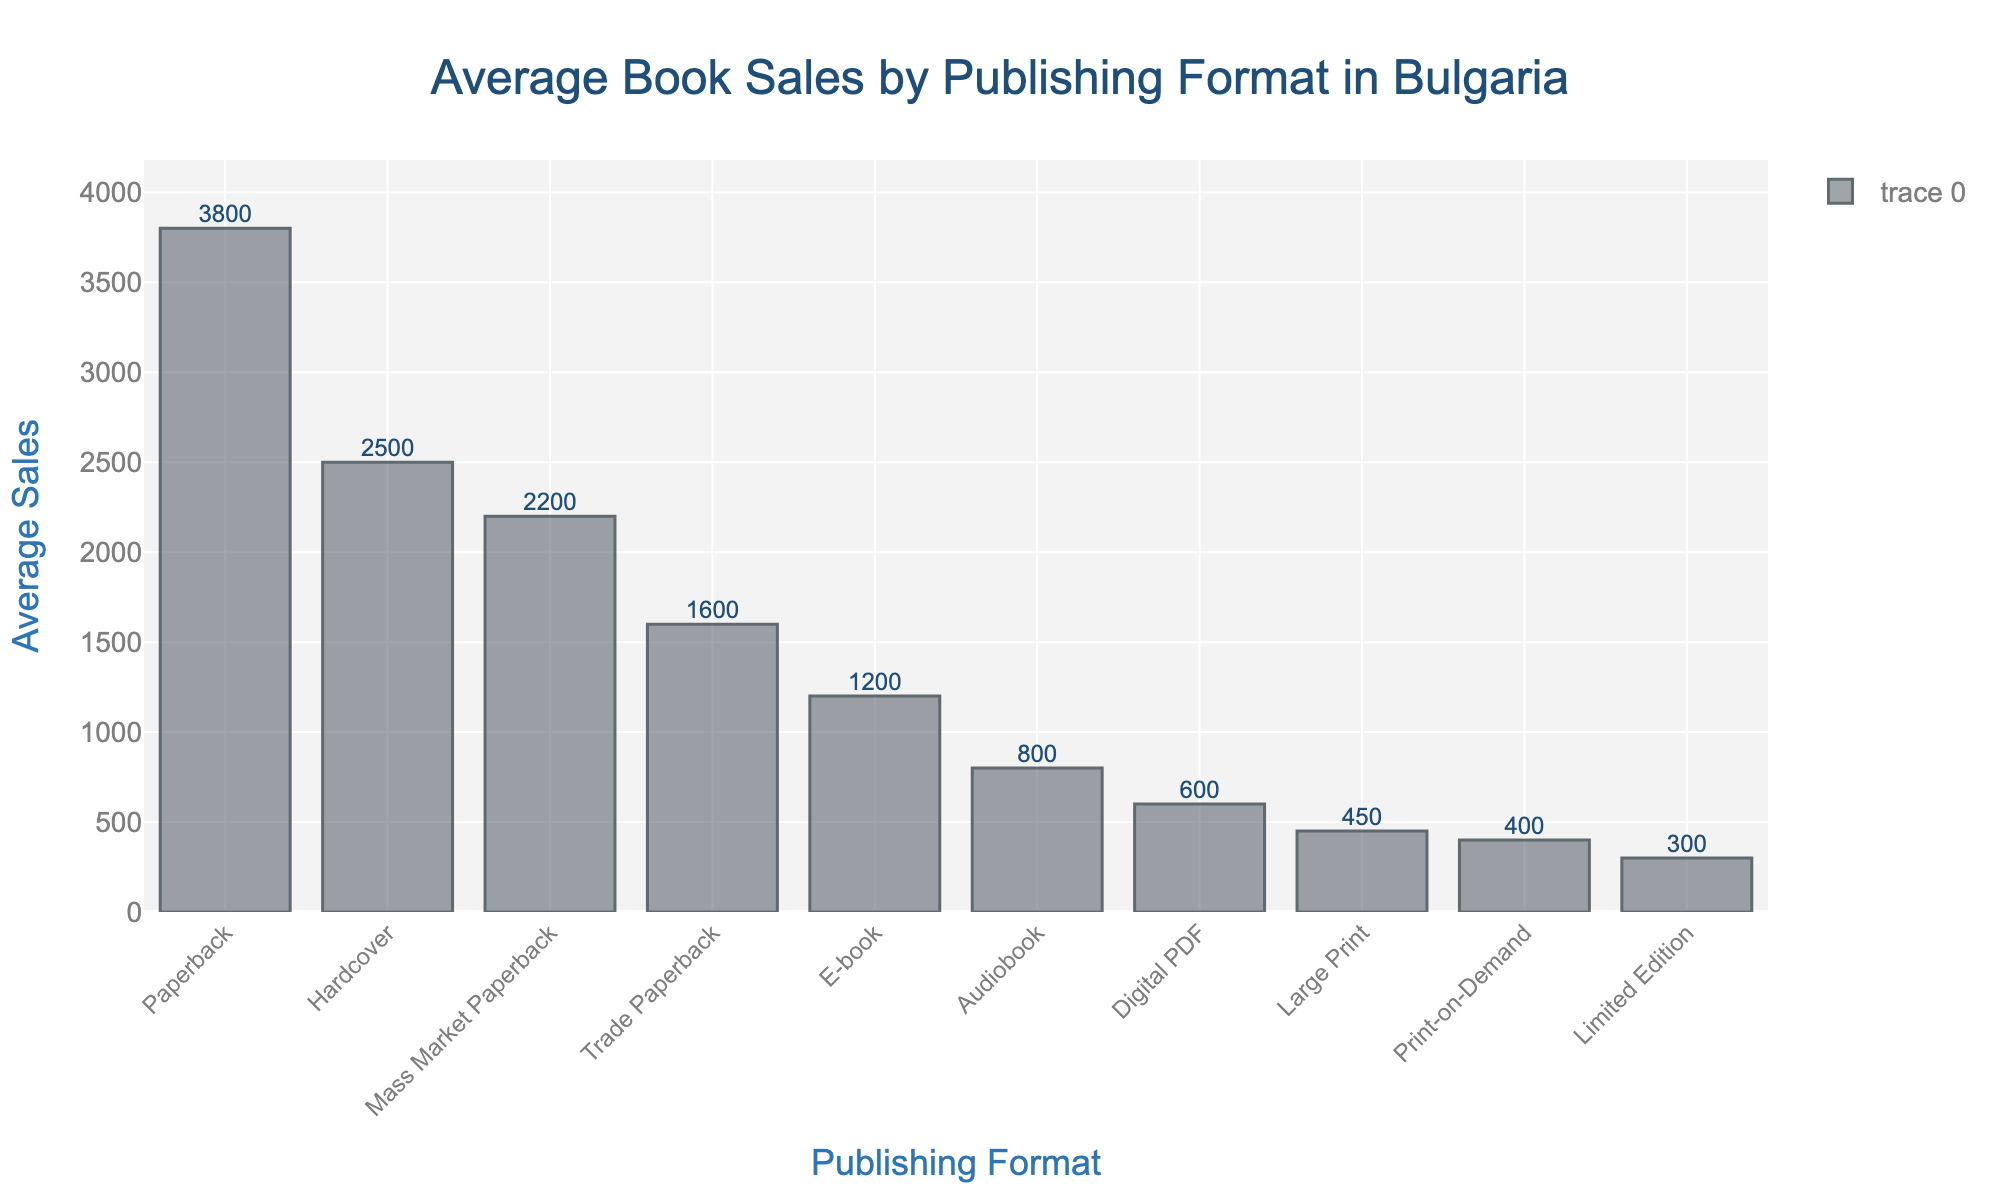Which publishing format has the highest average book sales? To identify the format with the highest average book sales, look for the tallest bar in the bar chart. The highest bar represents the "Paperback" format with 3800 average sales.
Answer: Paperback What is the difference in average sales between Hardcover and Trade Paperback formats? First, locate the bars for "Hardcover" and "Trade Paperback" formats. The "Hardcover" has 2500 average sales, while the "Trade Paperback" has 1600. Subtract the average sales of "Trade Paperback" from "Hardcover": 2500 - 1600 = 900.
Answer: 900 What is the combined average sales of Digital PDF and Audiobook formats? Find the bars representing both "Digital PDF" and "Audiobook". The "Digital PDF" has 600 average sales and the "Audiobook" has 800. Add these values together: 600 + 800 = 1400.
Answer: 1400 Which format has the lowest average book sales? Look for the shortest bar in the bar chart. The shortest bar represents the "Limited Edition" format with 300 average sales.
Answer: Limited Edition Are the average sales of Hardcover greater than those of Mass Market Paperback? Compare the heights of the bars for "Hardcover" and "Mass Market Paperback". The "Hardcover" has 2500 average sales whereas the "Mass Market Paperback" has 2200 average sales. Since 2500 > 2200, "Hardcover" has greater average sales.
Answer: Yes How much more popular are Paperbacks compared to E-books in terms of average sales? Locate the bars for "Paperback" and "E-book". The "Paperback" has 3800 average sales and the "E-book" has 1200. Subtract the average sales of "E-book" from "Paperback": 3800 - 1200 = 2600.
Answer: 2600 What is the average of the average sales values of Hardcover, Paperback, and E-book formats? Find the sales values for "Hardcover" (2500), "Paperback" (3800), and "E-book" (1200). Calculate their average: (2500 + 3800 + 1200) / 3 = 7500 / 3 = 2500.
Answer: 2500 